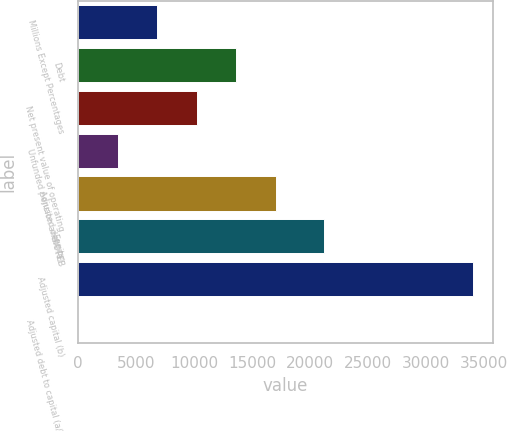Convert chart to OTSL. <chart><loc_0><loc_0><loc_500><loc_500><bar_chart><fcel>Millions Except Percentages<fcel>Debt<fcel>Net present value of operating<fcel>Unfunded pension and OPEB<fcel>Adjusted debt (a)<fcel>Equity<fcel>Adjusted capital (b)<fcel>Adjusted debt to capital (a/b)<nl><fcel>6835.88<fcel>13634.2<fcel>10235<fcel>3436.74<fcel>17033.3<fcel>21225<fcel>34029<fcel>37.6<nl></chart> 